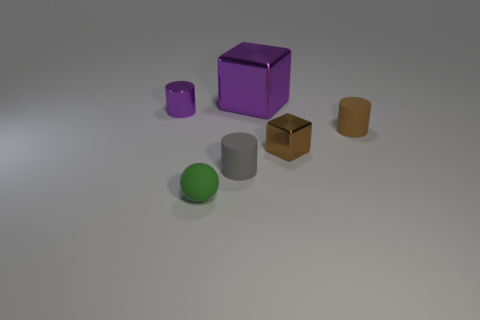Subtract all tiny matte cylinders. How many cylinders are left? 1 Subtract all purple cylinders. How many cylinders are left? 2 Add 4 large brown objects. How many objects exist? 10 Subtract all balls. How many objects are left? 5 Subtract 0 yellow spheres. How many objects are left? 6 Subtract 3 cylinders. How many cylinders are left? 0 Subtract all blue cylinders. Subtract all purple cubes. How many cylinders are left? 3 Subtract all blue balls. How many cyan cylinders are left? 0 Subtract all big purple things. Subtract all tiny brown rubber things. How many objects are left? 4 Add 5 gray cylinders. How many gray cylinders are left? 6 